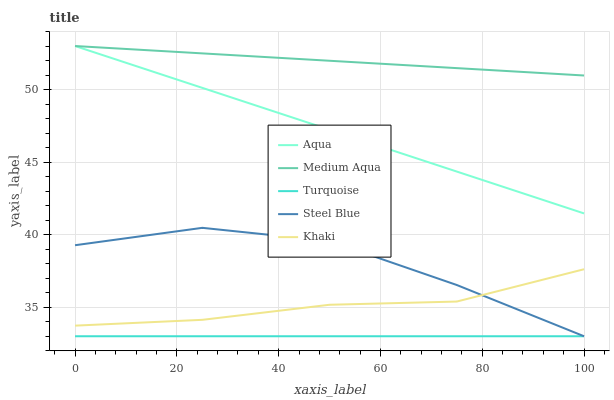Does Turquoise have the minimum area under the curve?
Answer yes or no. Yes. Does Medium Aqua have the maximum area under the curve?
Answer yes or no. Yes. Does Khaki have the minimum area under the curve?
Answer yes or no. No. Does Khaki have the maximum area under the curve?
Answer yes or no. No. Is Turquoise the smoothest?
Answer yes or no. Yes. Is Steel Blue the roughest?
Answer yes or no. Yes. Is Khaki the smoothest?
Answer yes or no. No. Is Khaki the roughest?
Answer yes or no. No. Does Turquoise have the lowest value?
Answer yes or no. Yes. Does Khaki have the lowest value?
Answer yes or no. No. Does Aqua have the highest value?
Answer yes or no. Yes. Does Khaki have the highest value?
Answer yes or no. No. Is Turquoise less than Khaki?
Answer yes or no. Yes. Is Aqua greater than Khaki?
Answer yes or no. Yes. Does Steel Blue intersect Turquoise?
Answer yes or no. Yes. Is Steel Blue less than Turquoise?
Answer yes or no. No. Is Steel Blue greater than Turquoise?
Answer yes or no. No. Does Turquoise intersect Khaki?
Answer yes or no. No. 